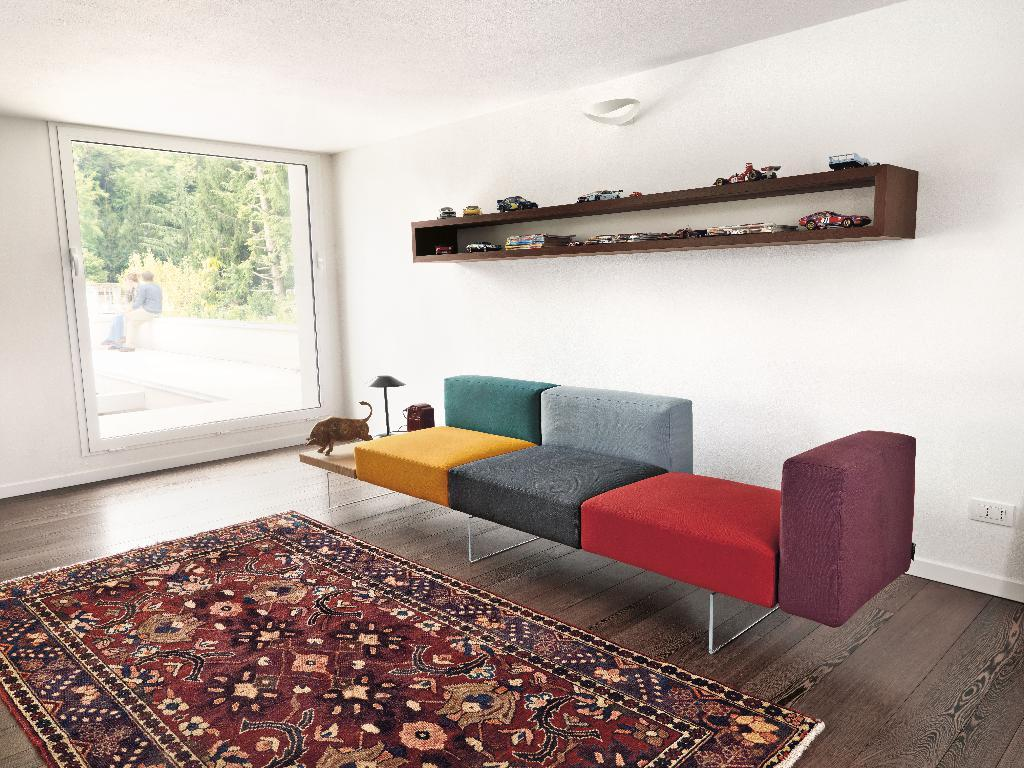What type of furniture is in the image? There is a sofa in the image. What is on the floor in the image? There is a carpet on the floor in the image. Where is the window located in the image? The window is on the left side of the image. What can be seen outside the window? Trees are visible outside the window. What is happening outside the window? There are people sitting outside the window. What type of government is depicted in the image? There is no depiction of a government in the image; it features a sofa, carpet, window, trees, and people sitting outside the window. How does the sofa adjust to accommodate more people? The sofa does not adjust in the image; it is stationary and does not change shape or size. 